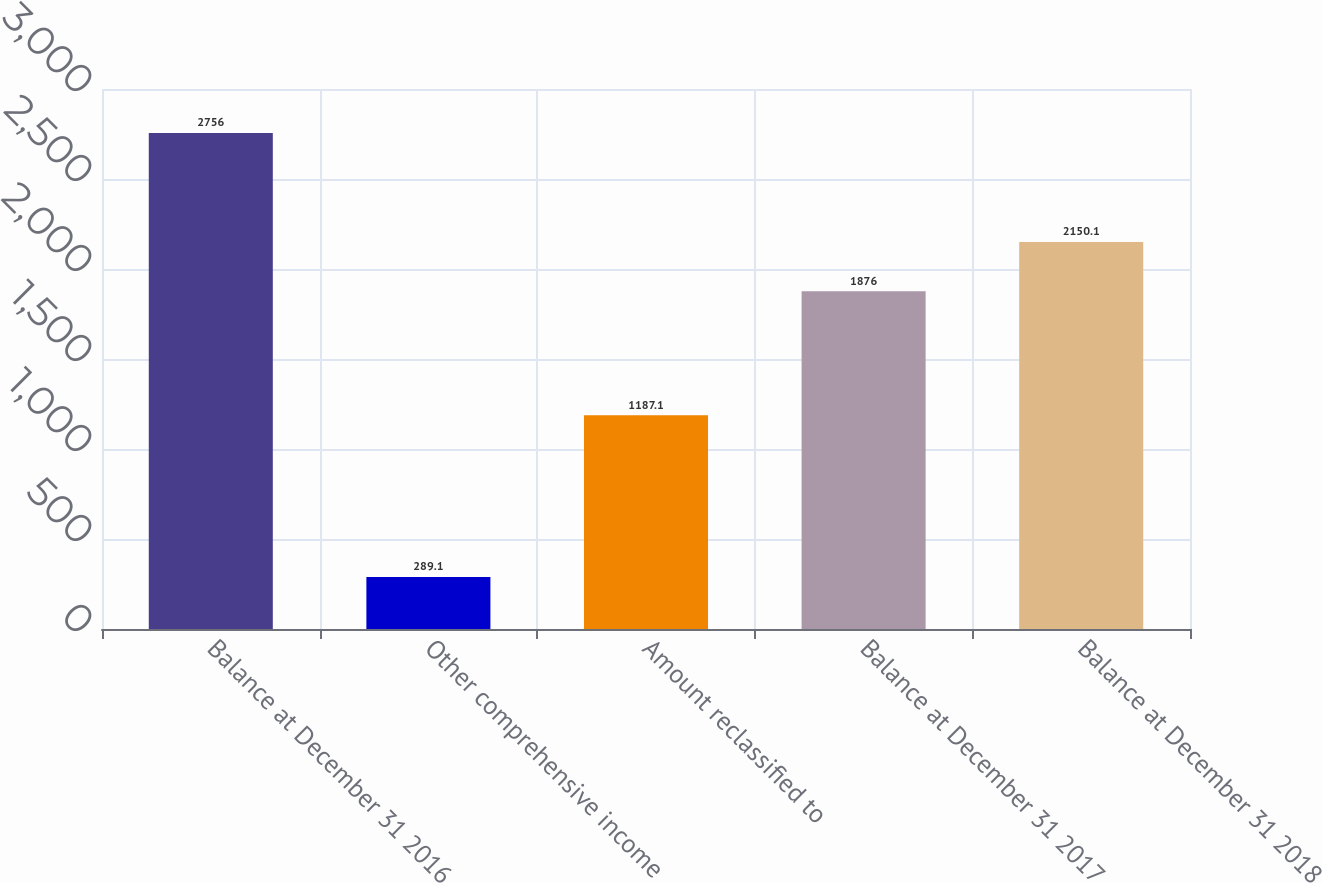Convert chart to OTSL. <chart><loc_0><loc_0><loc_500><loc_500><bar_chart><fcel>Balance at December 31 2016<fcel>Other comprehensive income<fcel>Amount reclassified to<fcel>Balance at December 31 2017<fcel>Balance at December 31 2018<nl><fcel>2756<fcel>289.1<fcel>1187.1<fcel>1876<fcel>2150.1<nl></chart> 